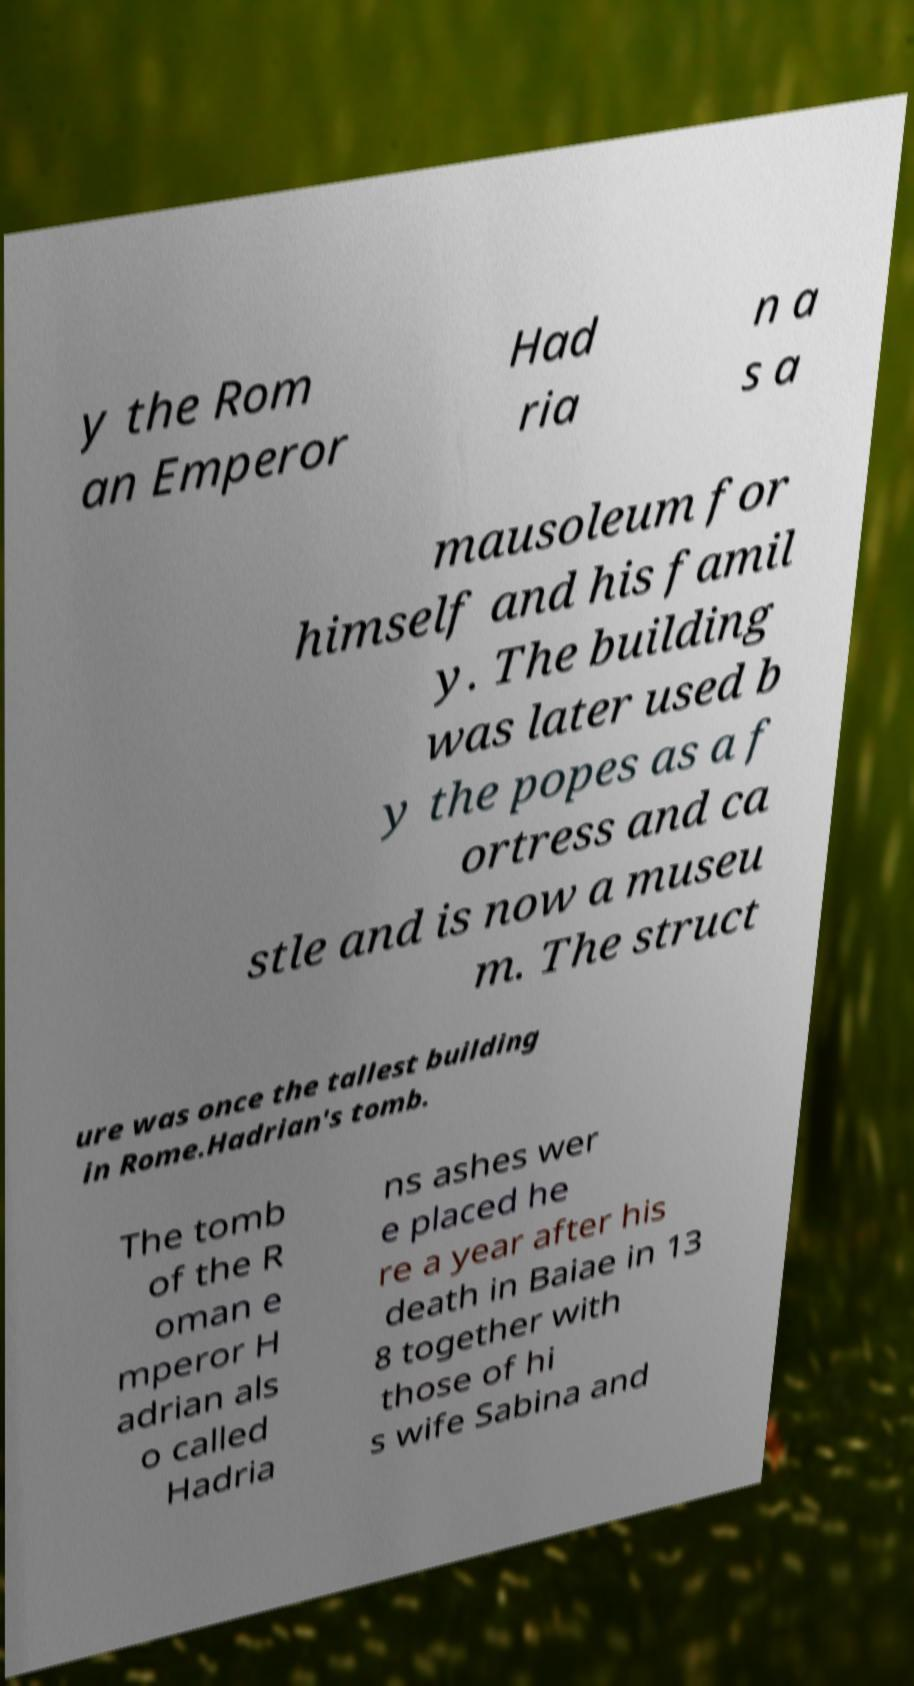Could you assist in decoding the text presented in this image and type it out clearly? y the Rom an Emperor Had ria n a s a mausoleum for himself and his famil y. The building was later used b y the popes as a f ortress and ca stle and is now a museu m. The struct ure was once the tallest building in Rome.Hadrian's tomb. The tomb of the R oman e mperor H adrian als o called Hadria ns ashes wer e placed he re a year after his death in Baiae in 13 8 together with those of hi s wife Sabina and 